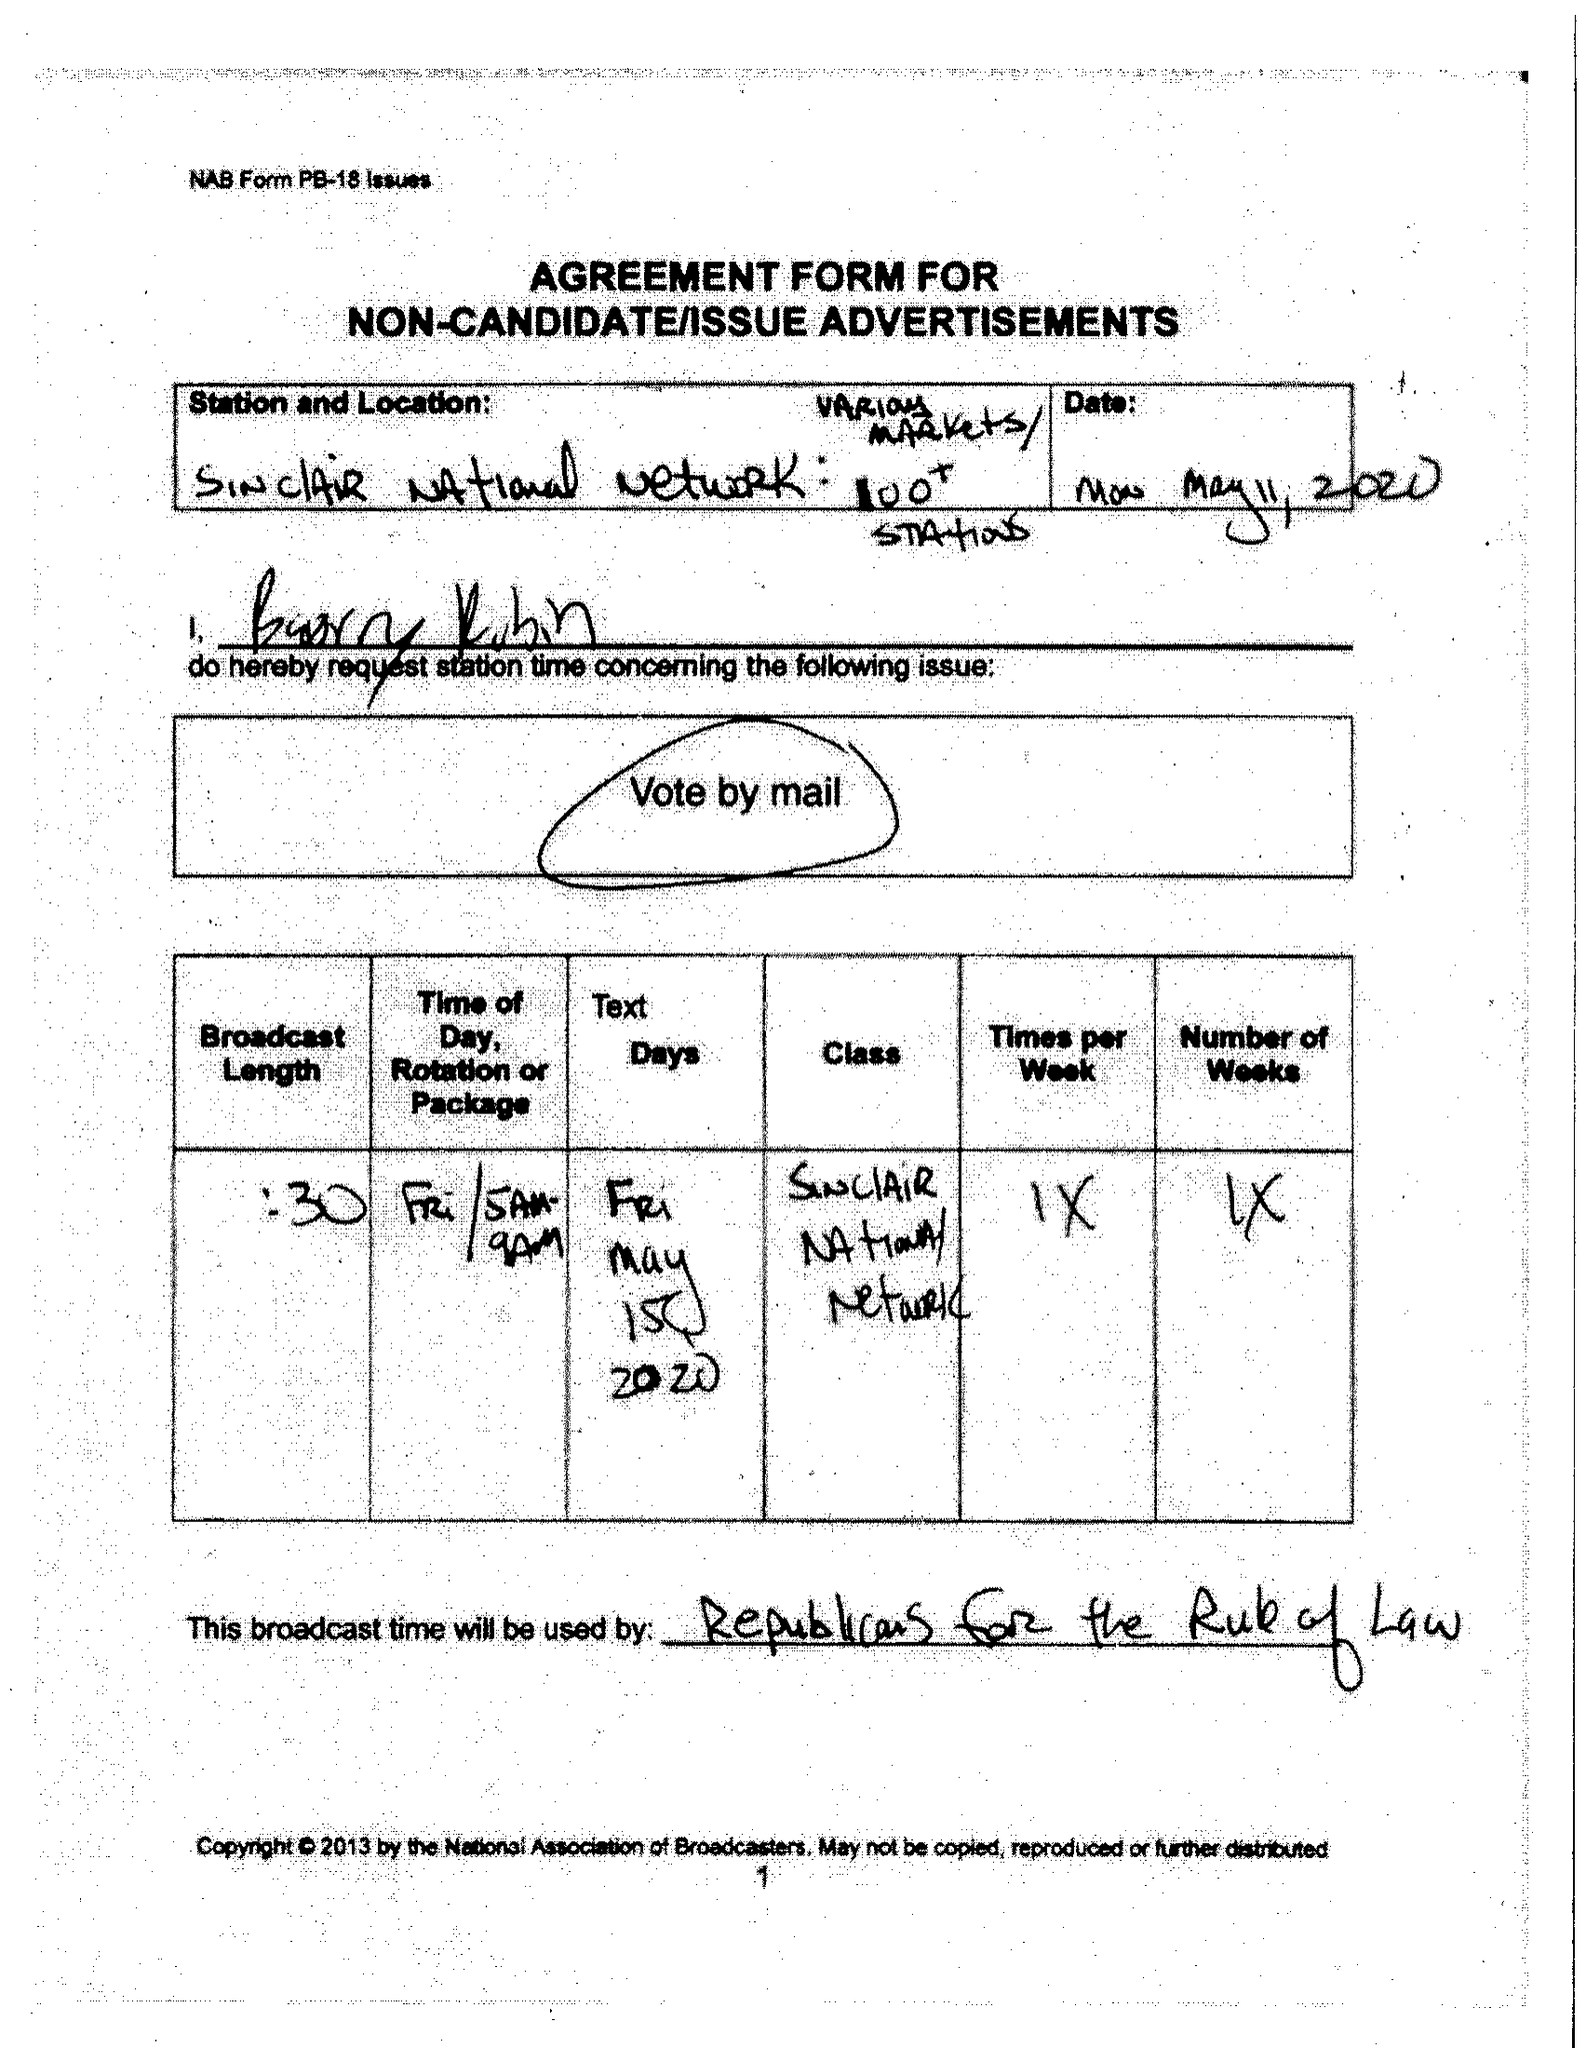What is the value for the gross_amount?
Answer the question using a single word or phrase. None 